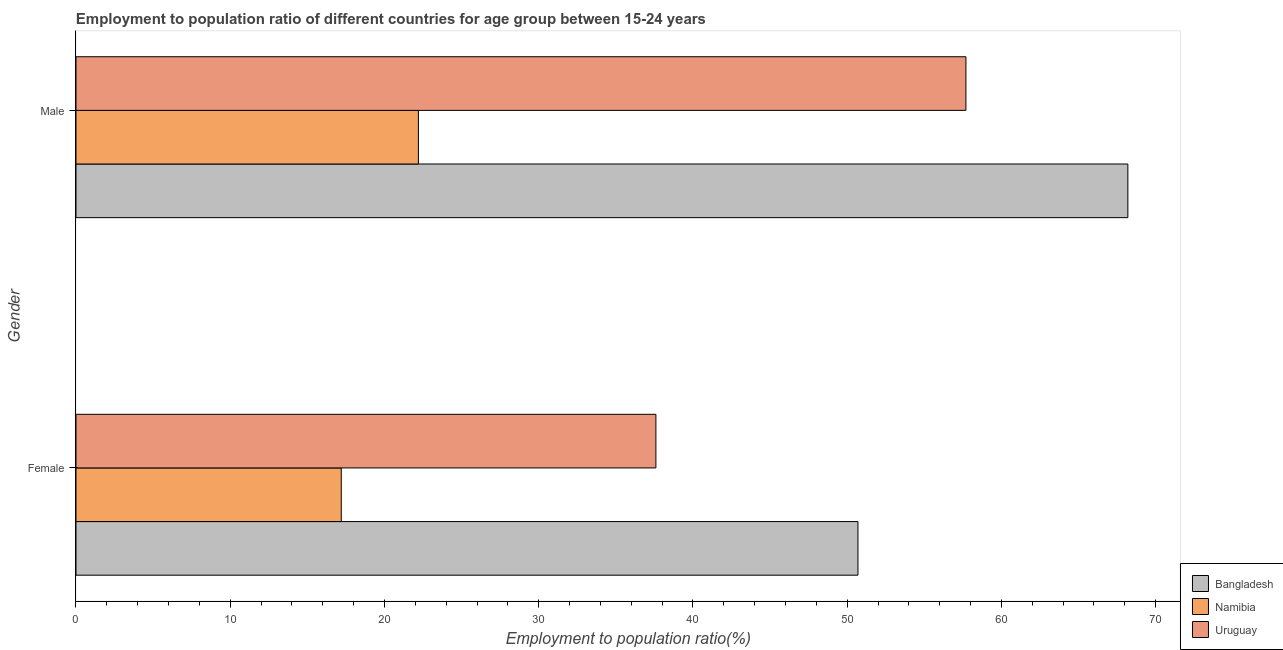How many different coloured bars are there?
Give a very brief answer. 3. Are the number of bars per tick equal to the number of legend labels?
Ensure brevity in your answer.  Yes. Are the number of bars on each tick of the Y-axis equal?
Offer a very short reply. Yes. How many bars are there on the 2nd tick from the bottom?
Your answer should be very brief. 3. What is the label of the 2nd group of bars from the top?
Your answer should be very brief. Female. What is the employment to population ratio(female) in Bangladesh?
Ensure brevity in your answer.  50.7. Across all countries, what is the maximum employment to population ratio(male)?
Your answer should be compact. 68.2. Across all countries, what is the minimum employment to population ratio(female)?
Offer a terse response. 17.2. In which country was the employment to population ratio(male) minimum?
Your answer should be very brief. Namibia. What is the total employment to population ratio(male) in the graph?
Offer a terse response. 148.1. What is the difference between the employment to population ratio(male) in Bangladesh and that in Uruguay?
Keep it short and to the point. 10.5. What is the difference between the employment to population ratio(male) in Bangladesh and the employment to population ratio(female) in Namibia?
Keep it short and to the point. 51. What is the average employment to population ratio(male) per country?
Keep it short and to the point. 49.37. What is the difference between the employment to population ratio(female) and employment to population ratio(male) in Bangladesh?
Ensure brevity in your answer.  -17.5. In how many countries, is the employment to population ratio(female) greater than 14 %?
Offer a terse response. 3. What is the ratio of the employment to population ratio(male) in Namibia to that in Uruguay?
Offer a terse response. 0.38. Is the employment to population ratio(female) in Uruguay less than that in Bangladesh?
Give a very brief answer. Yes. What does the 1st bar from the top in Male represents?
Give a very brief answer. Uruguay. How many bars are there?
Offer a terse response. 6. How many countries are there in the graph?
Your answer should be compact. 3. Does the graph contain any zero values?
Keep it short and to the point. No. Does the graph contain grids?
Your answer should be compact. No. How many legend labels are there?
Ensure brevity in your answer.  3. What is the title of the graph?
Give a very brief answer. Employment to population ratio of different countries for age group between 15-24 years. What is the Employment to population ratio(%) in Bangladesh in Female?
Offer a very short reply. 50.7. What is the Employment to population ratio(%) of Namibia in Female?
Offer a terse response. 17.2. What is the Employment to population ratio(%) of Uruguay in Female?
Give a very brief answer. 37.6. What is the Employment to population ratio(%) of Bangladesh in Male?
Give a very brief answer. 68.2. What is the Employment to population ratio(%) in Namibia in Male?
Ensure brevity in your answer.  22.2. What is the Employment to population ratio(%) in Uruguay in Male?
Offer a terse response. 57.7. Across all Gender, what is the maximum Employment to population ratio(%) of Bangladesh?
Give a very brief answer. 68.2. Across all Gender, what is the maximum Employment to population ratio(%) of Namibia?
Make the answer very short. 22.2. Across all Gender, what is the maximum Employment to population ratio(%) in Uruguay?
Offer a very short reply. 57.7. Across all Gender, what is the minimum Employment to population ratio(%) of Bangladesh?
Make the answer very short. 50.7. Across all Gender, what is the minimum Employment to population ratio(%) of Namibia?
Your answer should be compact. 17.2. Across all Gender, what is the minimum Employment to population ratio(%) in Uruguay?
Keep it short and to the point. 37.6. What is the total Employment to population ratio(%) of Bangladesh in the graph?
Offer a terse response. 118.9. What is the total Employment to population ratio(%) of Namibia in the graph?
Your response must be concise. 39.4. What is the total Employment to population ratio(%) in Uruguay in the graph?
Your answer should be very brief. 95.3. What is the difference between the Employment to population ratio(%) in Bangladesh in Female and that in Male?
Make the answer very short. -17.5. What is the difference between the Employment to population ratio(%) of Uruguay in Female and that in Male?
Your answer should be very brief. -20.1. What is the difference between the Employment to population ratio(%) in Bangladesh in Female and the Employment to population ratio(%) in Uruguay in Male?
Offer a terse response. -7. What is the difference between the Employment to population ratio(%) in Namibia in Female and the Employment to population ratio(%) in Uruguay in Male?
Offer a terse response. -40.5. What is the average Employment to population ratio(%) of Bangladesh per Gender?
Offer a terse response. 59.45. What is the average Employment to population ratio(%) of Namibia per Gender?
Offer a very short reply. 19.7. What is the average Employment to population ratio(%) of Uruguay per Gender?
Your answer should be compact. 47.65. What is the difference between the Employment to population ratio(%) of Bangladesh and Employment to population ratio(%) of Namibia in Female?
Your answer should be compact. 33.5. What is the difference between the Employment to population ratio(%) of Bangladesh and Employment to population ratio(%) of Uruguay in Female?
Offer a terse response. 13.1. What is the difference between the Employment to population ratio(%) in Namibia and Employment to population ratio(%) in Uruguay in Female?
Offer a very short reply. -20.4. What is the difference between the Employment to population ratio(%) of Bangladesh and Employment to population ratio(%) of Uruguay in Male?
Your response must be concise. 10.5. What is the difference between the Employment to population ratio(%) of Namibia and Employment to population ratio(%) of Uruguay in Male?
Provide a short and direct response. -35.5. What is the ratio of the Employment to population ratio(%) in Bangladesh in Female to that in Male?
Your response must be concise. 0.74. What is the ratio of the Employment to population ratio(%) in Namibia in Female to that in Male?
Provide a succinct answer. 0.77. What is the ratio of the Employment to population ratio(%) of Uruguay in Female to that in Male?
Provide a succinct answer. 0.65. What is the difference between the highest and the second highest Employment to population ratio(%) in Uruguay?
Your answer should be very brief. 20.1. What is the difference between the highest and the lowest Employment to population ratio(%) of Namibia?
Provide a short and direct response. 5. What is the difference between the highest and the lowest Employment to population ratio(%) in Uruguay?
Your answer should be compact. 20.1. 